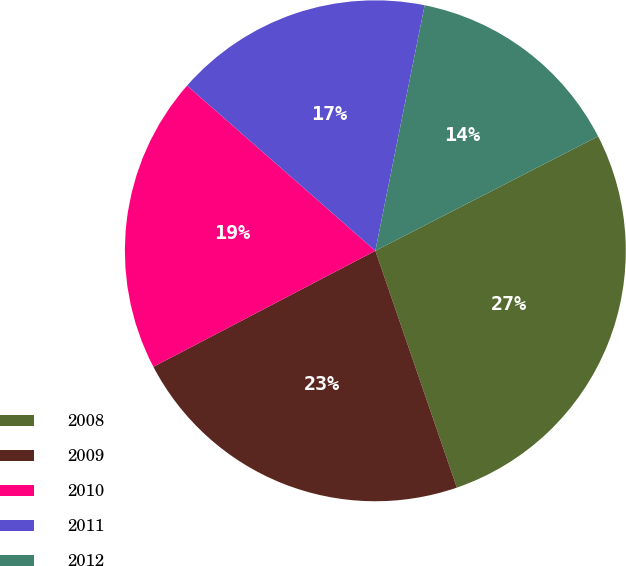<chart> <loc_0><loc_0><loc_500><loc_500><pie_chart><fcel>2008<fcel>2009<fcel>2010<fcel>2011<fcel>2012<nl><fcel>27.28%<fcel>22.61%<fcel>19.13%<fcel>16.69%<fcel>14.29%<nl></chart> 